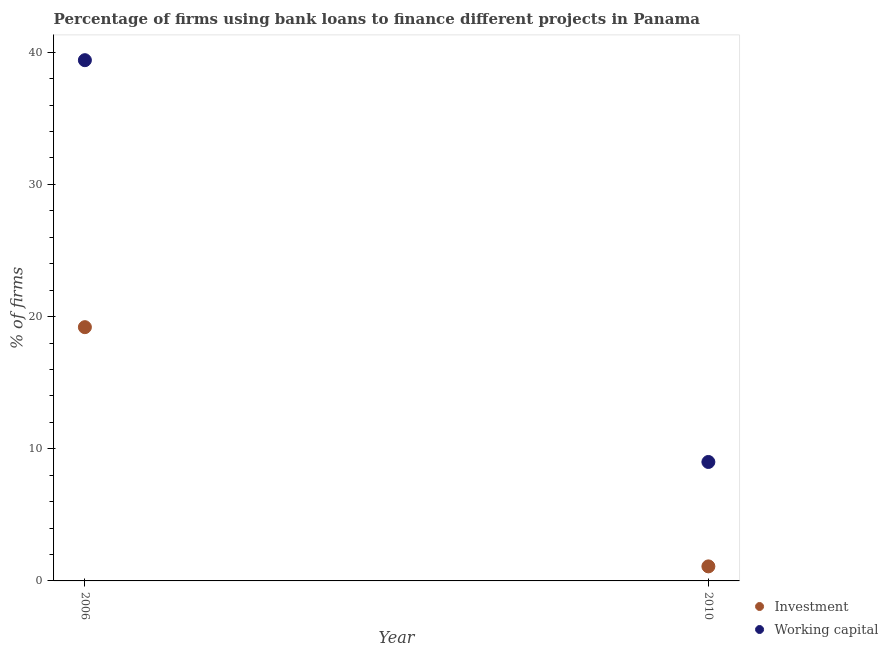Is the number of dotlines equal to the number of legend labels?
Offer a very short reply. Yes. What is the percentage of firms using banks to finance investment in 2010?
Your response must be concise. 1.1. In which year was the percentage of firms using banks to finance working capital minimum?
Provide a succinct answer. 2010. What is the total percentage of firms using banks to finance investment in the graph?
Make the answer very short. 20.3. What is the difference between the percentage of firms using banks to finance working capital in 2006 and that in 2010?
Your answer should be very brief. 30.4. What is the difference between the percentage of firms using banks to finance working capital in 2010 and the percentage of firms using banks to finance investment in 2006?
Make the answer very short. -10.2. What is the average percentage of firms using banks to finance working capital per year?
Your response must be concise. 24.2. What is the ratio of the percentage of firms using banks to finance working capital in 2006 to that in 2010?
Provide a succinct answer. 4.38. In how many years, is the percentage of firms using banks to finance investment greater than the average percentage of firms using banks to finance investment taken over all years?
Ensure brevity in your answer.  1. Does the percentage of firms using banks to finance working capital monotonically increase over the years?
Ensure brevity in your answer.  No. Is the percentage of firms using banks to finance investment strictly greater than the percentage of firms using banks to finance working capital over the years?
Your response must be concise. No. How many years are there in the graph?
Your response must be concise. 2. Are the values on the major ticks of Y-axis written in scientific E-notation?
Your answer should be very brief. No. Does the graph contain grids?
Give a very brief answer. No. How many legend labels are there?
Keep it short and to the point. 2. How are the legend labels stacked?
Provide a succinct answer. Vertical. What is the title of the graph?
Offer a terse response. Percentage of firms using bank loans to finance different projects in Panama. Does "From Government" appear as one of the legend labels in the graph?
Provide a succinct answer. No. What is the label or title of the Y-axis?
Make the answer very short. % of firms. What is the % of firms of Investment in 2006?
Ensure brevity in your answer.  19.2. What is the % of firms in Working capital in 2006?
Provide a succinct answer. 39.4. What is the % of firms of Investment in 2010?
Ensure brevity in your answer.  1.1. Across all years, what is the maximum % of firms in Working capital?
Offer a terse response. 39.4. Across all years, what is the minimum % of firms of Investment?
Make the answer very short. 1.1. Across all years, what is the minimum % of firms of Working capital?
Ensure brevity in your answer.  9. What is the total % of firms of Investment in the graph?
Your answer should be very brief. 20.3. What is the total % of firms of Working capital in the graph?
Offer a terse response. 48.4. What is the difference between the % of firms of Investment in 2006 and that in 2010?
Your answer should be very brief. 18.1. What is the difference between the % of firms of Working capital in 2006 and that in 2010?
Provide a short and direct response. 30.4. What is the average % of firms of Investment per year?
Give a very brief answer. 10.15. What is the average % of firms in Working capital per year?
Make the answer very short. 24.2. In the year 2006, what is the difference between the % of firms of Investment and % of firms of Working capital?
Offer a very short reply. -20.2. In the year 2010, what is the difference between the % of firms in Investment and % of firms in Working capital?
Ensure brevity in your answer.  -7.9. What is the ratio of the % of firms in Investment in 2006 to that in 2010?
Ensure brevity in your answer.  17.45. What is the ratio of the % of firms of Working capital in 2006 to that in 2010?
Offer a terse response. 4.38. What is the difference between the highest and the second highest % of firms in Working capital?
Give a very brief answer. 30.4. What is the difference between the highest and the lowest % of firms of Investment?
Keep it short and to the point. 18.1. What is the difference between the highest and the lowest % of firms in Working capital?
Your answer should be very brief. 30.4. 